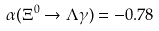<formula> <loc_0><loc_0><loc_500><loc_500>\alpha ( \Xi ^ { 0 } \to \Lambda \gamma ) = - 0 . 7 8</formula> 